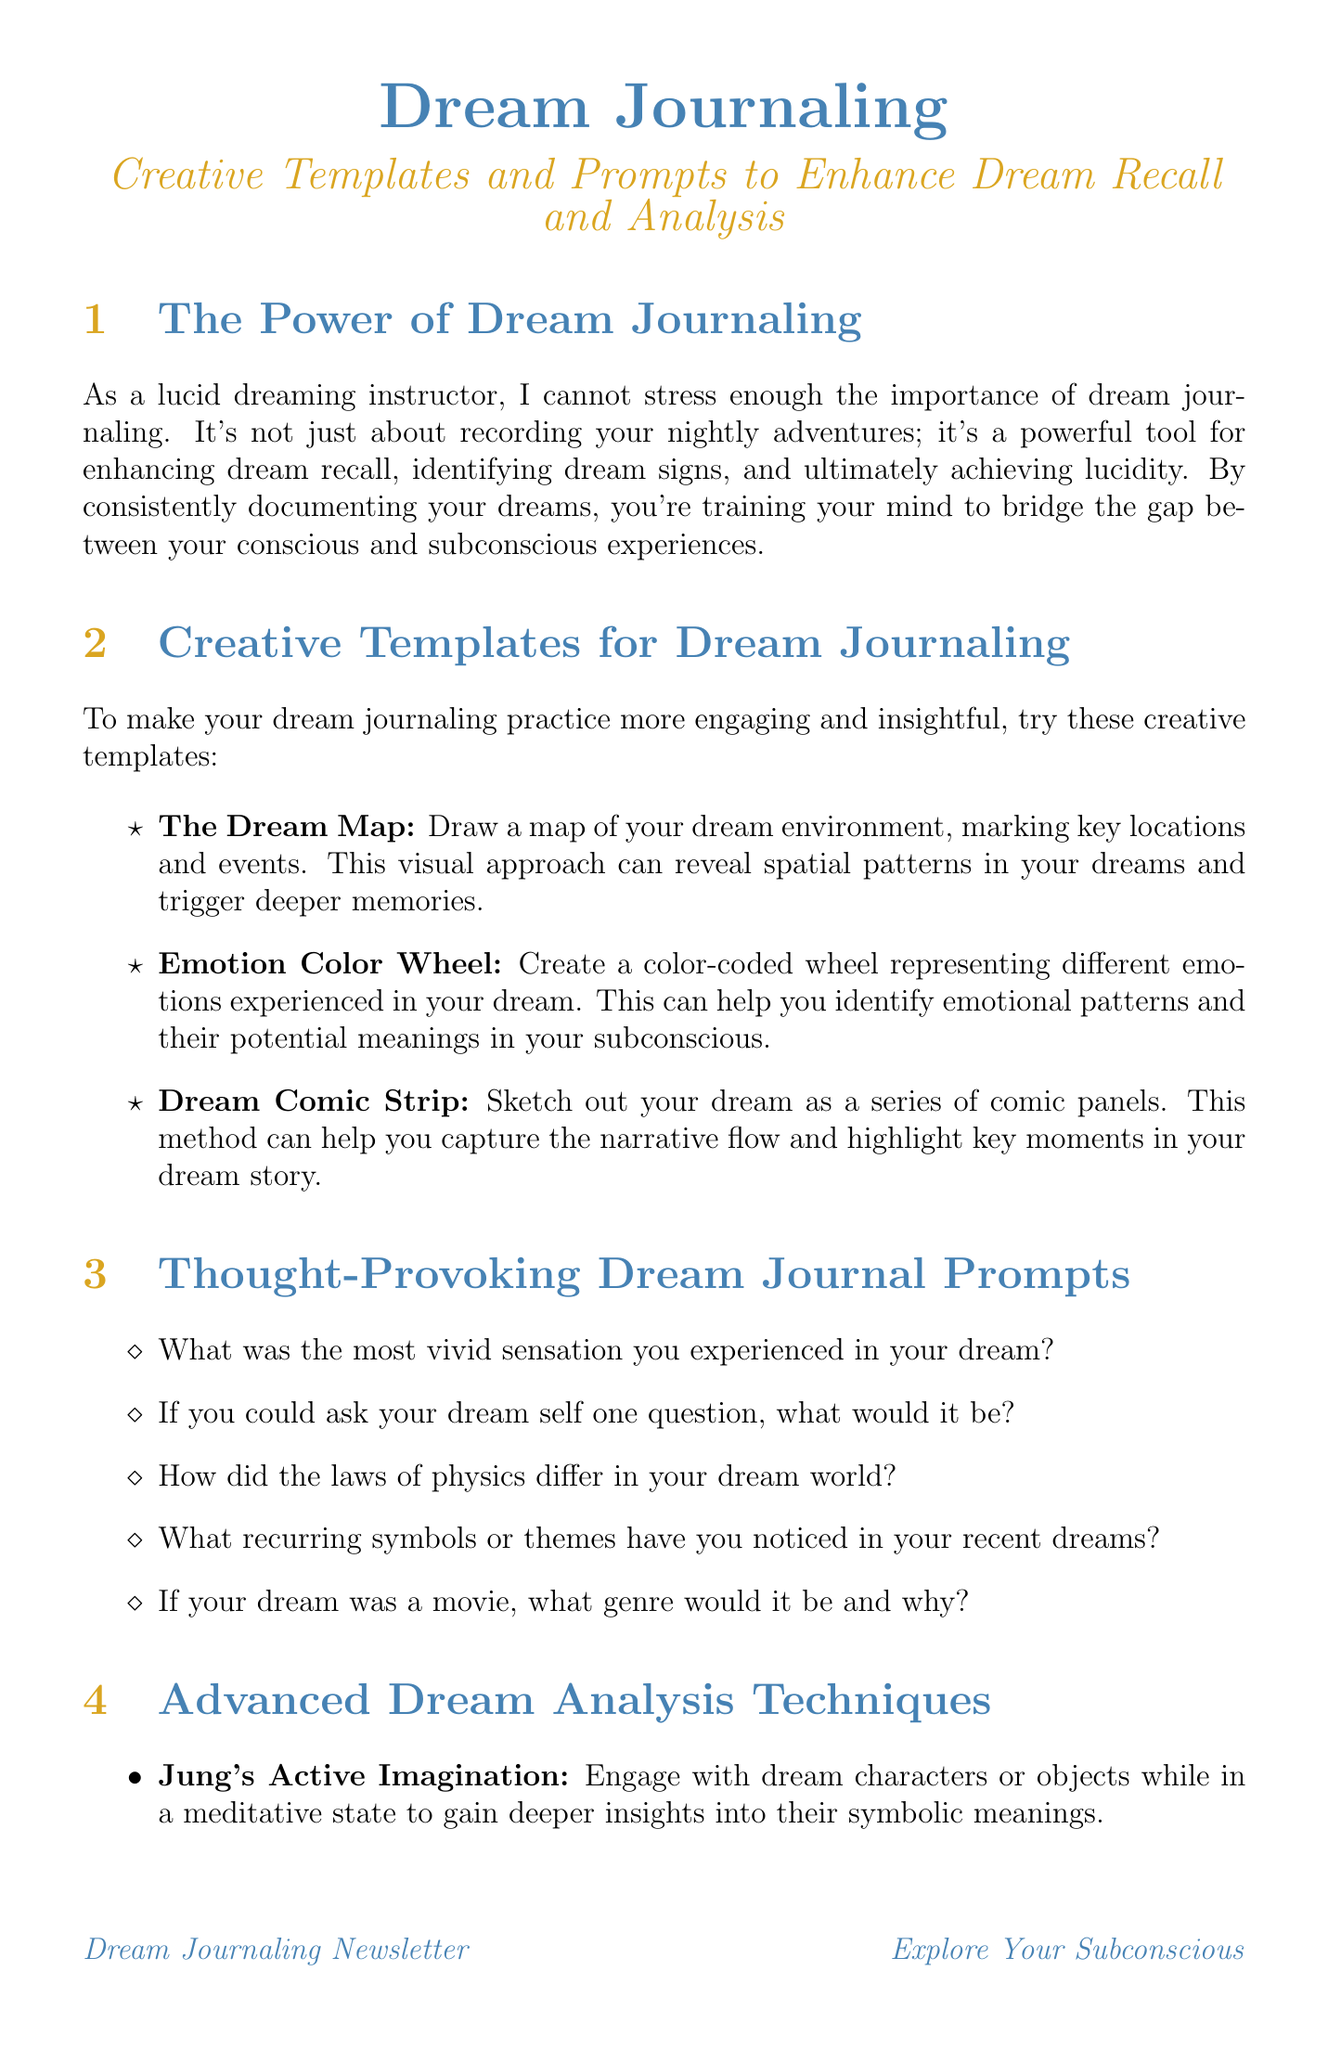What is the title of this newsletter? The title of the newsletter is indicated prominently at the beginning of the document.
Answer: Dream Journaling How many creative templates are suggested for dream journaling? The document lists three creative templates in the section dedicated to them.
Answer: 3 What technique involves engaging with dream characters in a meditative state? The document describes several techniques, one of which specifically involves this method for deeper insights.
Answer: Jung's Active Imagination What is one example of a thought-provoking dream journal prompt? The document provides a list of prompts, and any one of them can be used as an example.
Answer: What was the most vivid sensation you experienced in your dream? Which mobile app is recommended for dream journaling? The newsletter includes specific tools and mentions the name of a mobile application suitable for dream journaling.
Answer: Dream Journal Ultimate 